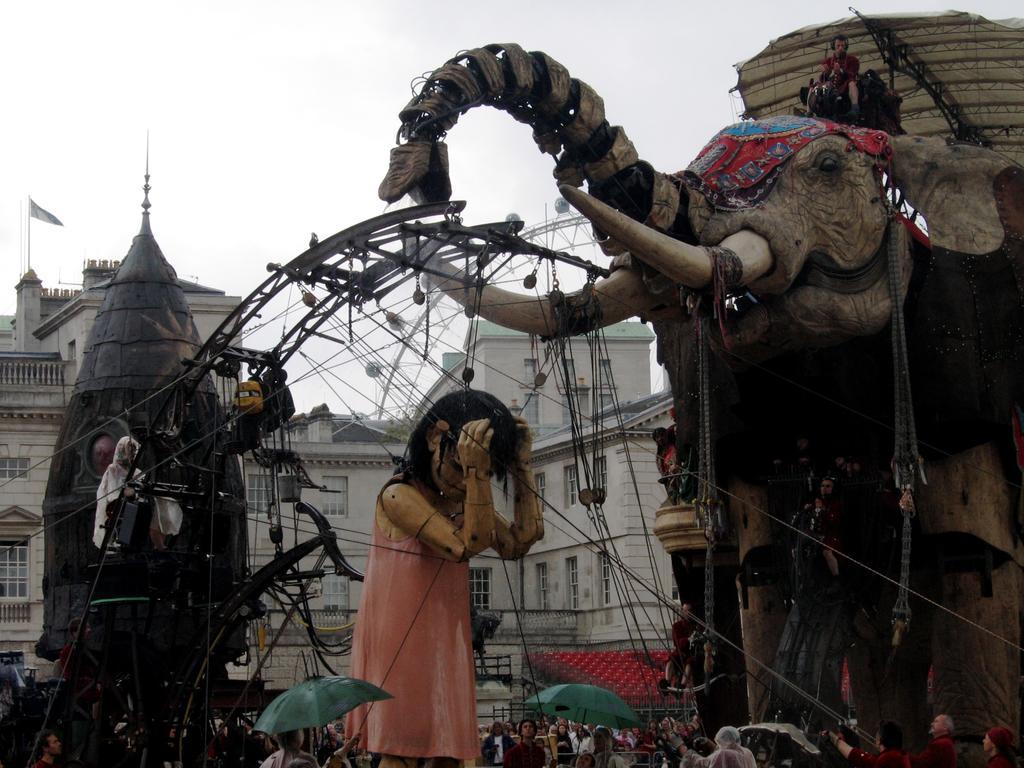How would you summarize this image in a sentence or two? In this image we can see a statue tied with ropes. Also there is a statue of an elephant. At the bottom we can see many people. There are umbrellas. In the background there is a building with windows. Also there is sky. 